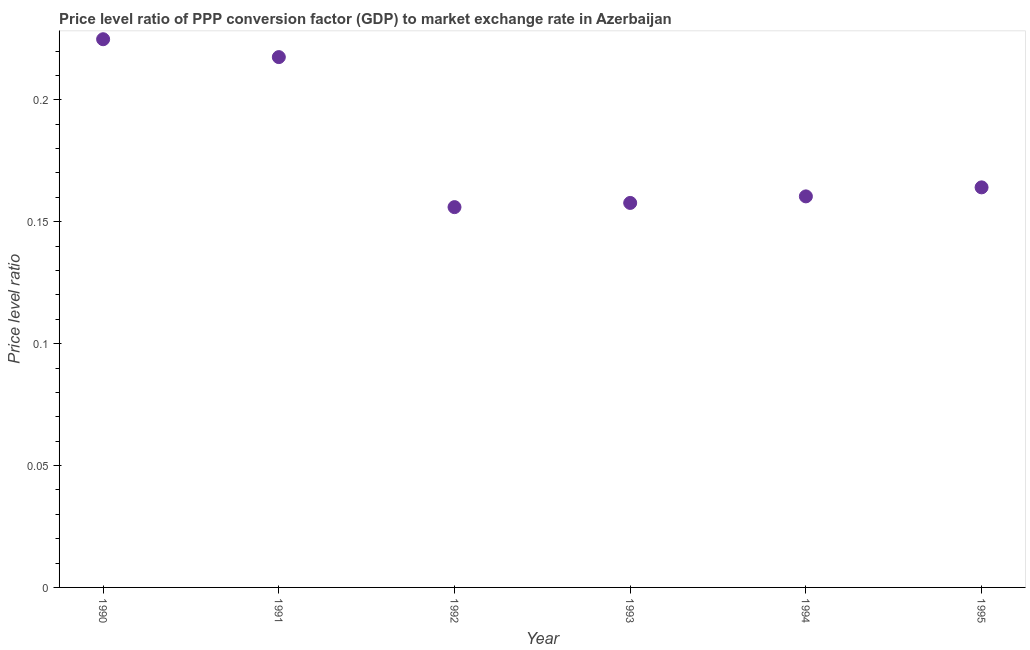What is the price level ratio in 1993?
Provide a short and direct response. 0.16. Across all years, what is the maximum price level ratio?
Provide a succinct answer. 0.22. Across all years, what is the minimum price level ratio?
Your response must be concise. 0.16. What is the sum of the price level ratio?
Provide a succinct answer. 1.08. What is the difference between the price level ratio in 1990 and 1991?
Offer a terse response. 0.01. What is the average price level ratio per year?
Provide a succinct answer. 0.18. What is the median price level ratio?
Your response must be concise. 0.16. What is the ratio of the price level ratio in 1990 to that in 1993?
Provide a short and direct response. 1.43. Is the price level ratio in 1992 less than that in 1994?
Ensure brevity in your answer.  Yes. What is the difference between the highest and the second highest price level ratio?
Ensure brevity in your answer.  0.01. What is the difference between the highest and the lowest price level ratio?
Provide a short and direct response. 0.07. In how many years, is the price level ratio greater than the average price level ratio taken over all years?
Your answer should be compact. 2. Does the price level ratio monotonically increase over the years?
Offer a very short reply. No. What is the difference between two consecutive major ticks on the Y-axis?
Keep it short and to the point. 0.05. Does the graph contain grids?
Your answer should be very brief. No. What is the title of the graph?
Provide a short and direct response. Price level ratio of PPP conversion factor (GDP) to market exchange rate in Azerbaijan. What is the label or title of the X-axis?
Make the answer very short. Year. What is the label or title of the Y-axis?
Your answer should be compact. Price level ratio. What is the Price level ratio in 1990?
Give a very brief answer. 0.22. What is the Price level ratio in 1991?
Offer a terse response. 0.22. What is the Price level ratio in 1992?
Your answer should be very brief. 0.16. What is the Price level ratio in 1993?
Provide a succinct answer. 0.16. What is the Price level ratio in 1994?
Offer a terse response. 0.16. What is the Price level ratio in 1995?
Offer a very short reply. 0.16. What is the difference between the Price level ratio in 1990 and 1991?
Make the answer very short. 0.01. What is the difference between the Price level ratio in 1990 and 1992?
Offer a very short reply. 0.07. What is the difference between the Price level ratio in 1990 and 1993?
Keep it short and to the point. 0.07. What is the difference between the Price level ratio in 1990 and 1994?
Your answer should be very brief. 0.06. What is the difference between the Price level ratio in 1990 and 1995?
Offer a very short reply. 0.06. What is the difference between the Price level ratio in 1991 and 1992?
Your answer should be very brief. 0.06. What is the difference between the Price level ratio in 1991 and 1993?
Keep it short and to the point. 0.06. What is the difference between the Price level ratio in 1991 and 1994?
Offer a very short reply. 0.06. What is the difference between the Price level ratio in 1991 and 1995?
Provide a succinct answer. 0.05. What is the difference between the Price level ratio in 1992 and 1993?
Provide a short and direct response. -0. What is the difference between the Price level ratio in 1992 and 1994?
Make the answer very short. -0. What is the difference between the Price level ratio in 1992 and 1995?
Your answer should be very brief. -0.01. What is the difference between the Price level ratio in 1993 and 1994?
Offer a very short reply. -0. What is the difference between the Price level ratio in 1993 and 1995?
Provide a short and direct response. -0.01. What is the difference between the Price level ratio in 1994 and 1995?
Keep it short and to the point. -0. What is the ratio of the Price level ratio in 1990 to that in 1991?
Give a very brief answer. 1.03. What is the ratio of the Price level ratio in 1990 to that in 1992?
Your answer should be compact. 1.44. What is the ratio of the Price level ratio in 1990 to that in 1993?
Give a very brief answer. 1.43. What is the ratio of the Price level ratio in 1990 to that in 1994?
Your response must be concise. 1.4. What is the ratio of the Price level ratio in 1990 to that in 1995?
Provide a succinct answer. 1.37. What is the ratio of the Price level ratio in 1991 to that in 1992?
Make the answer very short. 1.39. What is the ratio of the Price level ratio in 1991 to that in 1993?
Offer a terse response. 1.38. What is the ratio of the Price level ratio in 1991 to that in 1994?
Your answer should be very brief. 1.36. What is the ratio of the Price level ratio in 1991 to that in 1995?
Keep it short and to the point. 1.33. What is the ratio of the Price level ratio in 1992 to that in 1993?
Offer a terse response. 0.99. What is the ratio of the Price level ratio in 1992 to that in 1995?
Give a very brief answer. 0.95. What is the ratio of the Price level ratio in 1993 to that in 1994?
Offer a very short reply. 0.98. What is the ratio of the Price level ratio in 1993 to that in 1995?
Give a very brief answer. 0.96. 